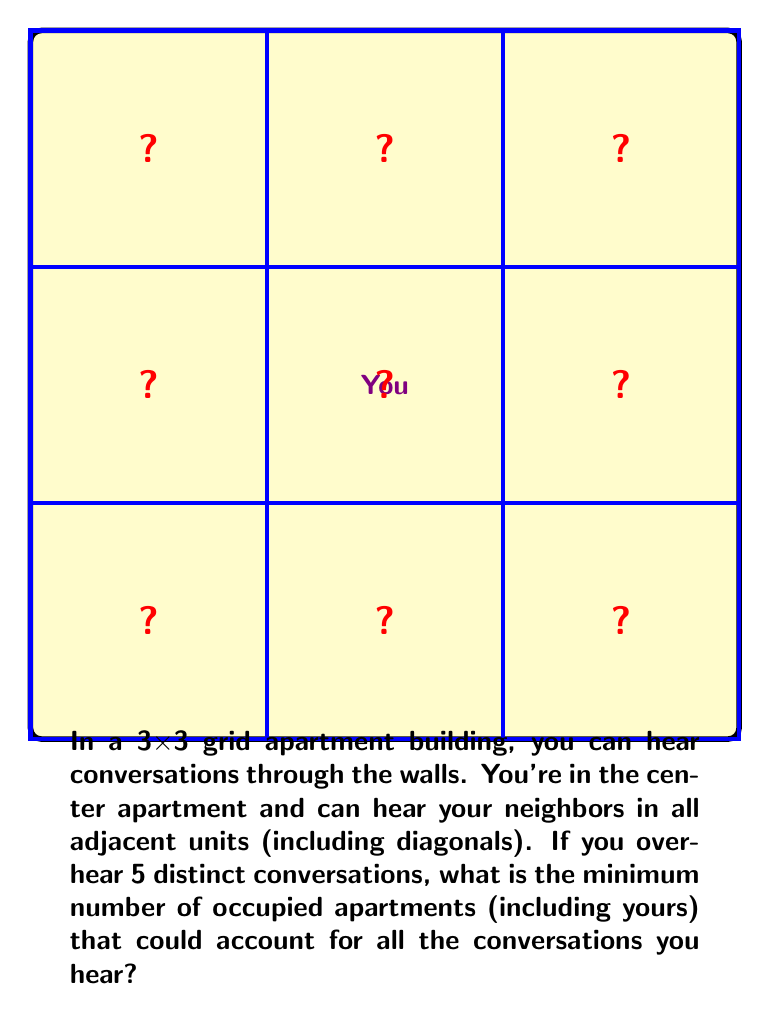Can you answer this question? Let's approach this step-by-step:

1) You are in the center apartment, so that's one occupied apartment.

2) You can hear conversations from all 8 surrounding apartments.

3) To minimize the number of occupied apartments while hearing 5 distinct conversations, we need to place the other residents optimally.

4) The most efficient arrangement is to place the other residents in the corner apartments. This way, each resident can contribute to two conversations you hear (through the walls and diagonally).

5) With you in the center and residents in two corners, we have:
   - 1 (you) + 2 (corner residents) = 3 occupied apartments
   - 1 (your apartment) + 2 (conversations through walls) + 2 (diagonal conversations) = 5 distinct conversations

6) This arrangement satisfies the conditions with the minimum number of occupied apartments.

7) We can represent this mathematically as:
   $$N_{occupied} = 1 + \lceil\frac{N_{conversations} - 1}{2}\rceil$$
   Where $N_{occupied}$ is the minimum number of occupied apartments and $N_{conversations}$ is the number of distinct conversations heard.

8) In this case:
   $$N_{occupied} = 1 + \lceil\frac{5 - 1}{2}\rceil = 1 + \lceil2\rceil = 3$$

Therefore, the minimum number of occupied apartments is 3.
Answer: 3 